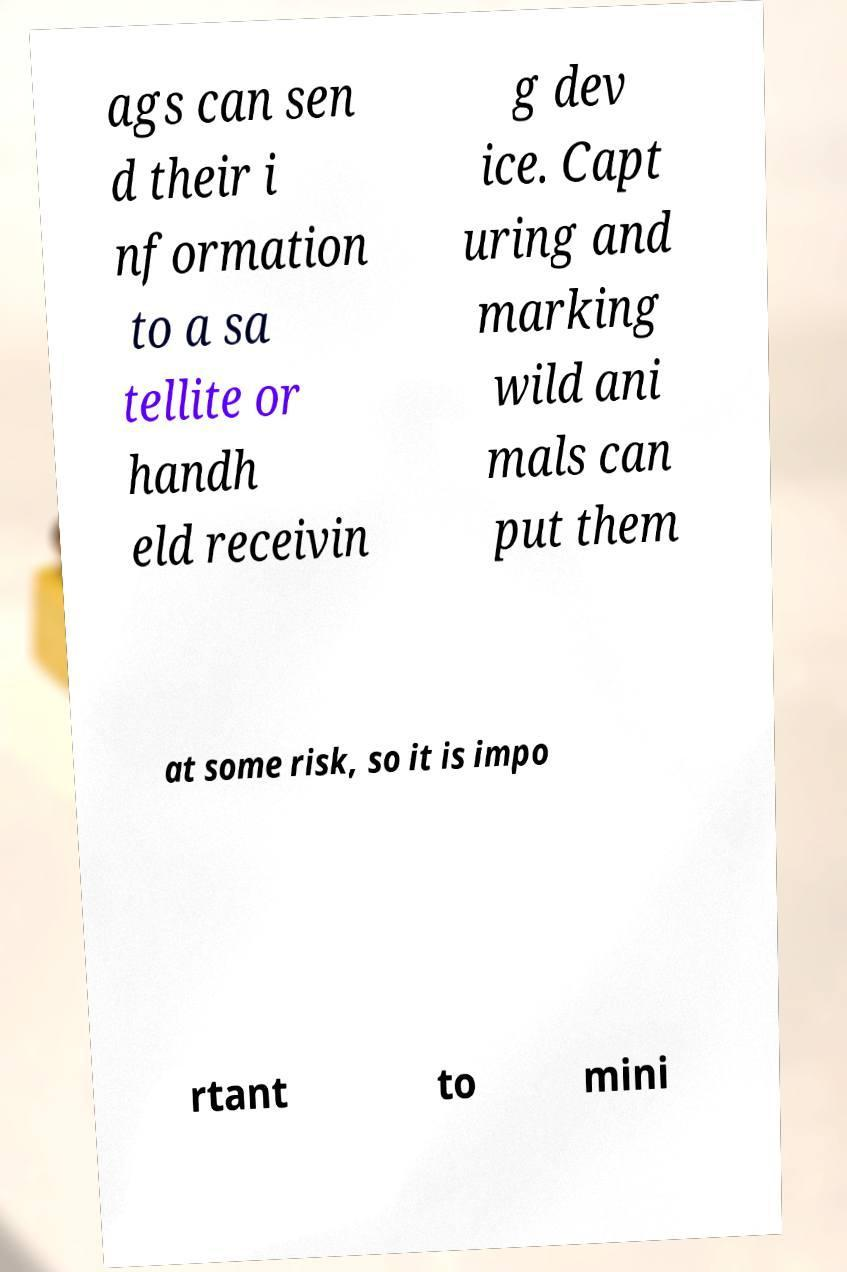Please read and relay the text visible in this image. What does it say? ags can sen d their i nformation to a sa tellite or handh eld receivin g dev ice. Capt uring and marking wild ani mals can put them at some risk, so it is impo rtant to mini 